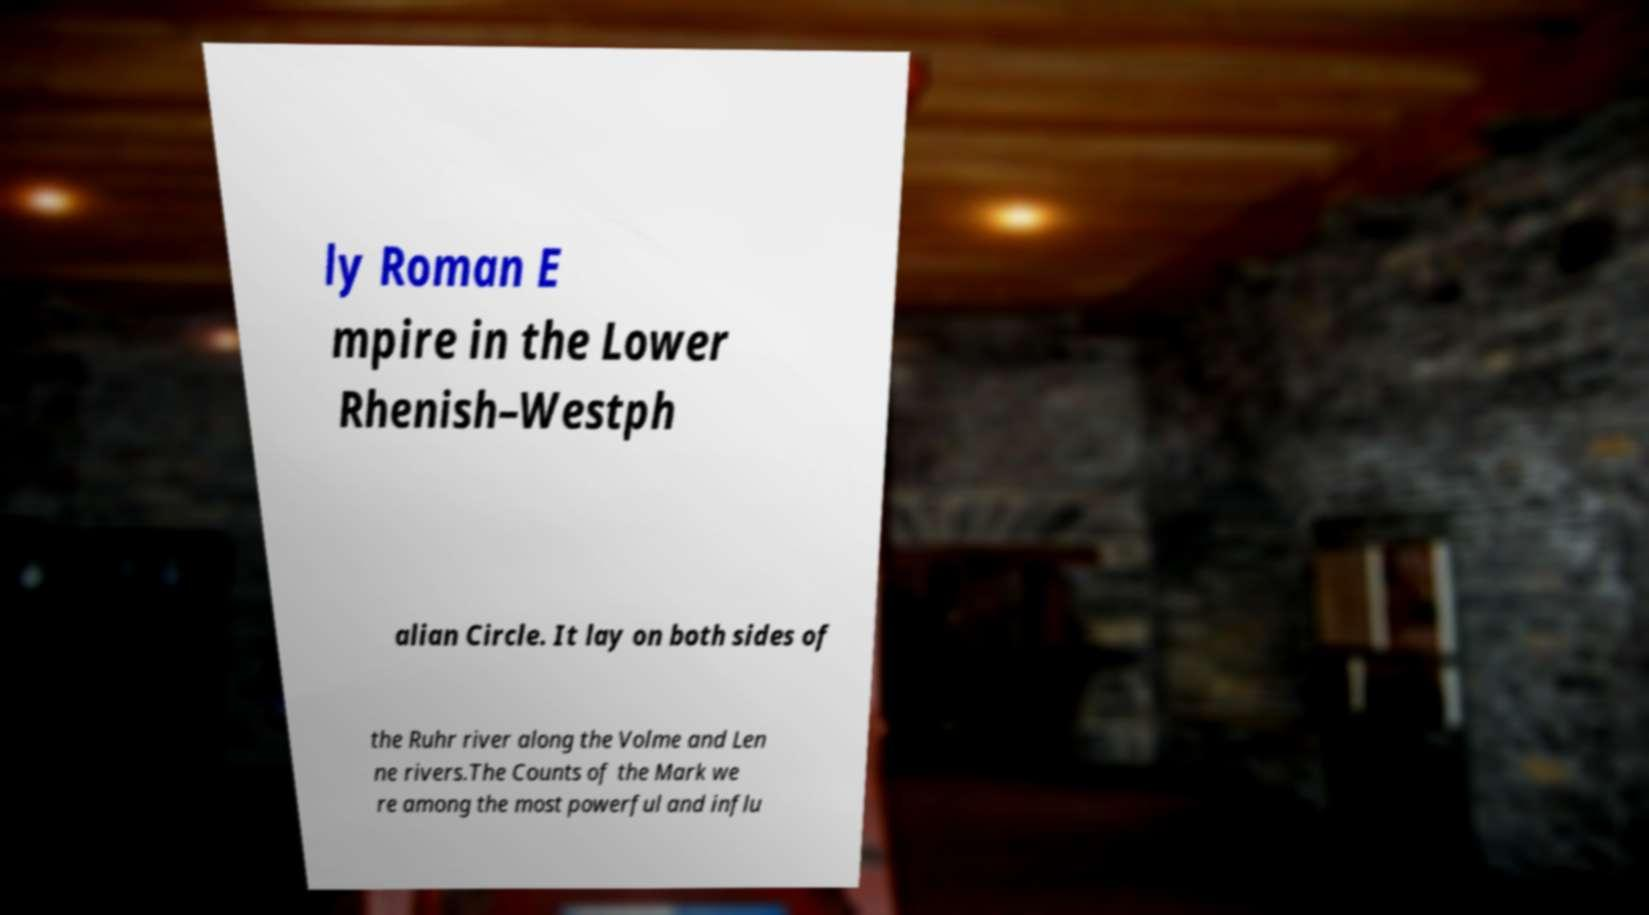Could you assist in decoding the text presented in this image and type it out clearly? ly Roman E mpire in the Lower Rhenish–Westph alian Circle. It lay on both sides of the Ruhr river along the Volme and Len ne rivers.The Counts of the Mark we re among the most powerful and influ 